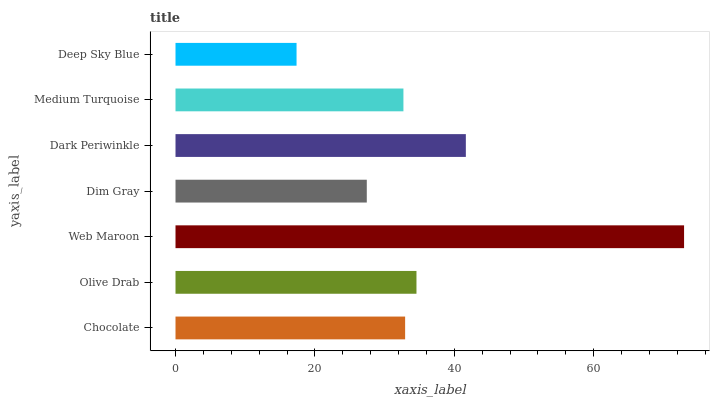Is Deep Sky Blue the minimum?
Answer yes or no. Yes. Is Web Maroon the maximum?
Answer yes or no. Yes. Is Olive Drab the minimum?
Answer yes or no. No. Is Olive Drab the maximum?
Answer yes or no. No. Is Olive Drab greater than Chocolate?
Answer yes or no. Yes. Is Chocolate less than Olive Drab?
Answer yes or no. Yes. Is Chocolate greater than Olive Drab?
Answer yes or no. No. Is Olive Drab less than Chocolate?
Answer yes or no. No. Is Chocolate the high median?
Answer yes or no. Yes. Is Chocolate the low median?
Answer yes or no. Yes. Is Olive Drab the high median?
Answer yes or no. No. Is Dark Periwinkle the low median?
Answer yes or no. No. 